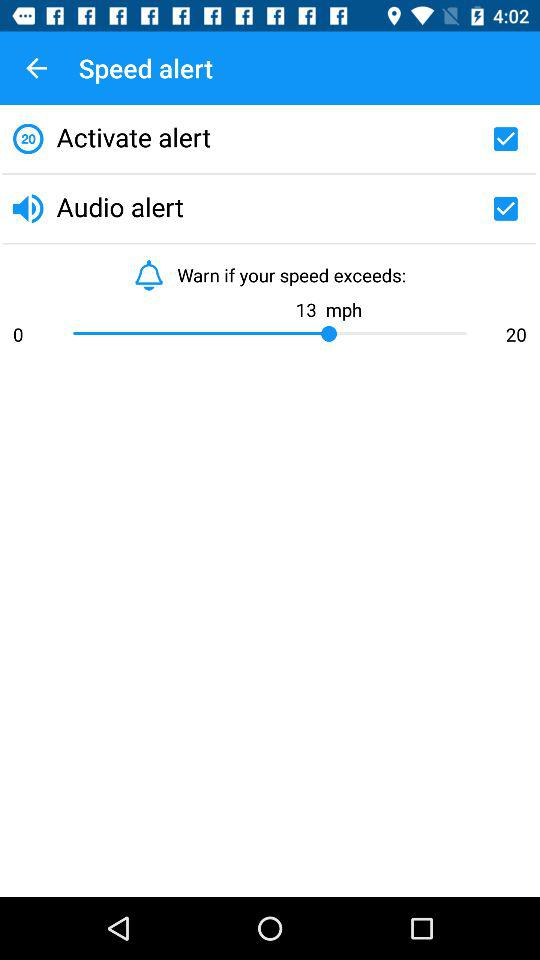What is the status of "Activate alert"? The status of "Activate alert" is "on". 